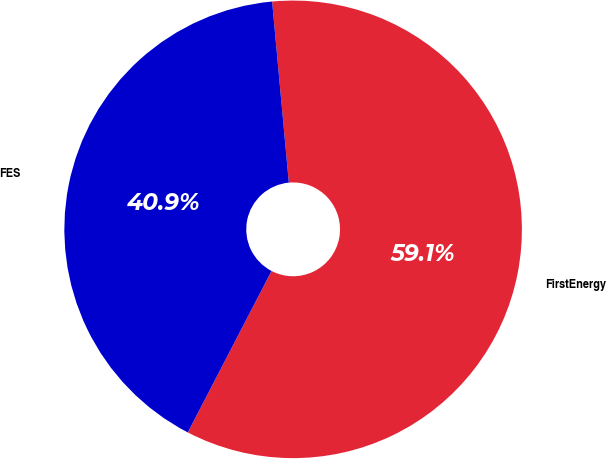Convert chart to OTSL. <chart><loc_0><loc_0><loc_500><loc_500><pie_chart><fcel>FirstEnergy<fcel>FES<nl><fcel>59.08%<fcel>40.92%<nl></chart> 